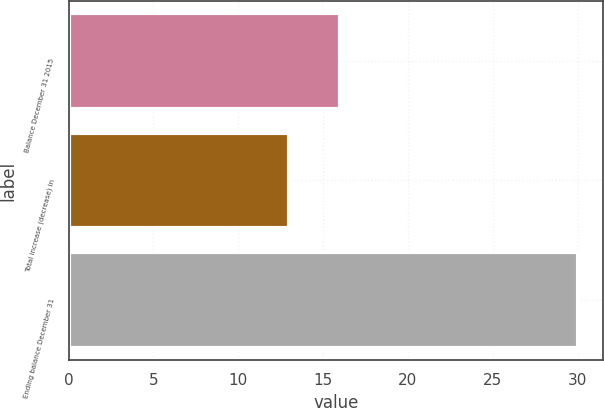Convert chart to OTSL. <chart><loc_0><loc_0><loc_500><loc_500><bar_chart><fcel>Balance December 31 2015<fcel>Total increase (decrease) in<fcel>Ending balance December 31<nl><fcel>16<fcel>13<fcel>30<nl></chart> 